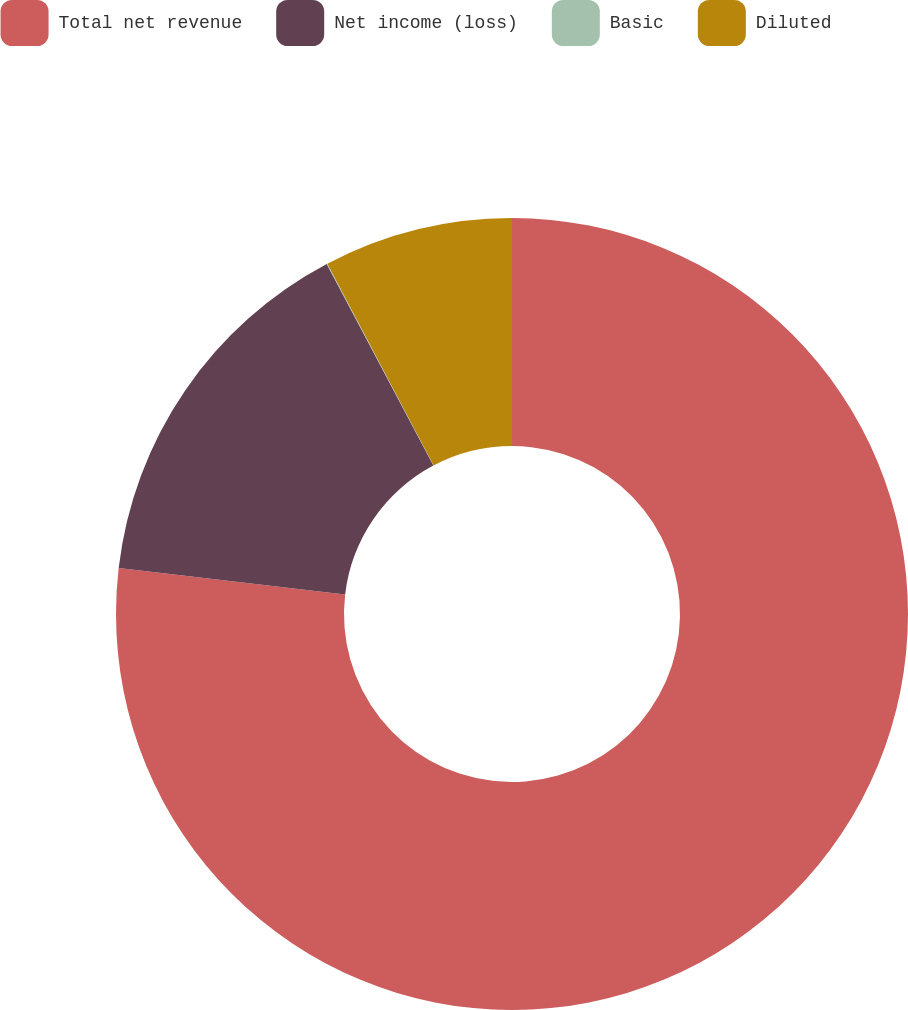<chart> <loc_0><loc_0><loc_500><loc_500><pie_chart><fcel>Total net revenue<fcel>Net income (loss)<fcel>Basic<fcel>Diluted<nl><fcel>76.85%<fcel>15.4%<fcel>0.03%<fcel>7.72%<nl></chart> 